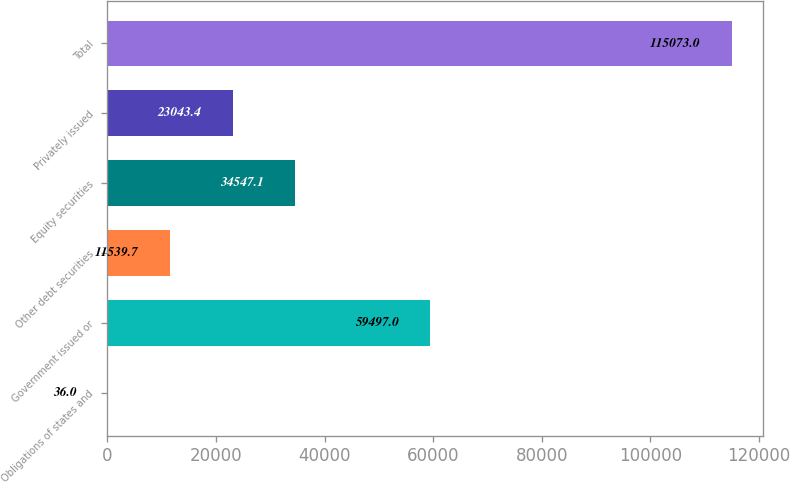<chart> <loc_0><loc_0><loc_500><loc_500><bar_chart><fcel>Obligations of states and<fcel>Government issued or<fcel>Other debt securities<fcel>Equity securities<fcel>Privately issued<fcel>Total<nl><fcel>36<fcel>59497<fcel>11539.7<fcel>34547.1<fcel>23043.4<fcel>115073<nl></chart> 